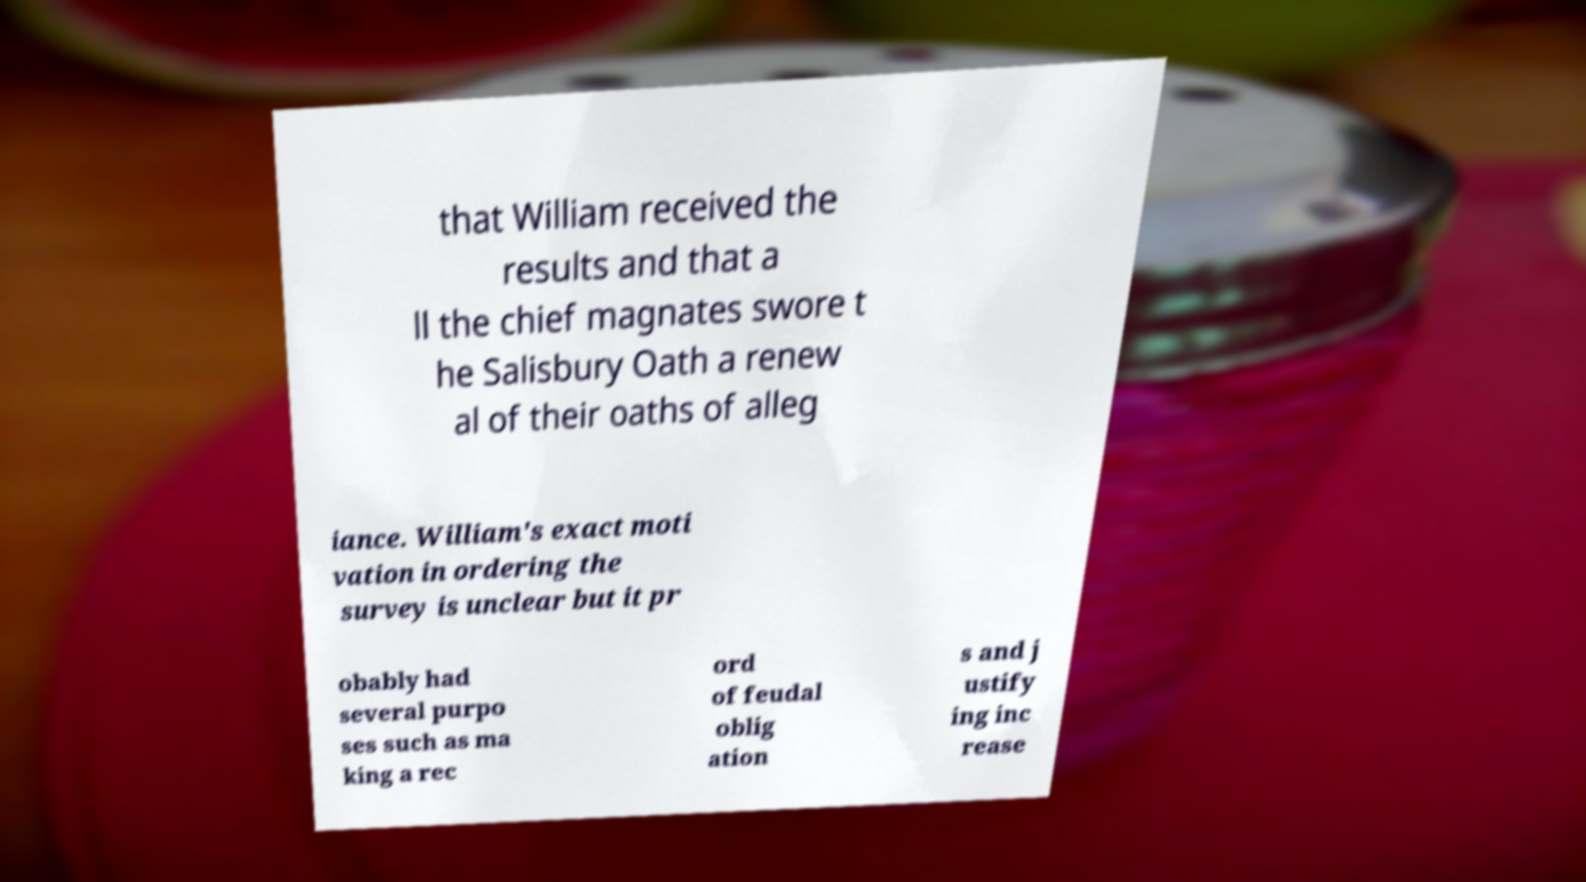Please identify and transcribe the text found in this image. that William received the results and that a ll the chief magnates swore t he Salisbury Oath a renew al of their oaths of alleg iance. William's exact moti vation in ordering the survey is unclear but it pr obably had several purpo ses such as ma king a rec ord of feudal oblig ation s and j ustify ing inc rease 